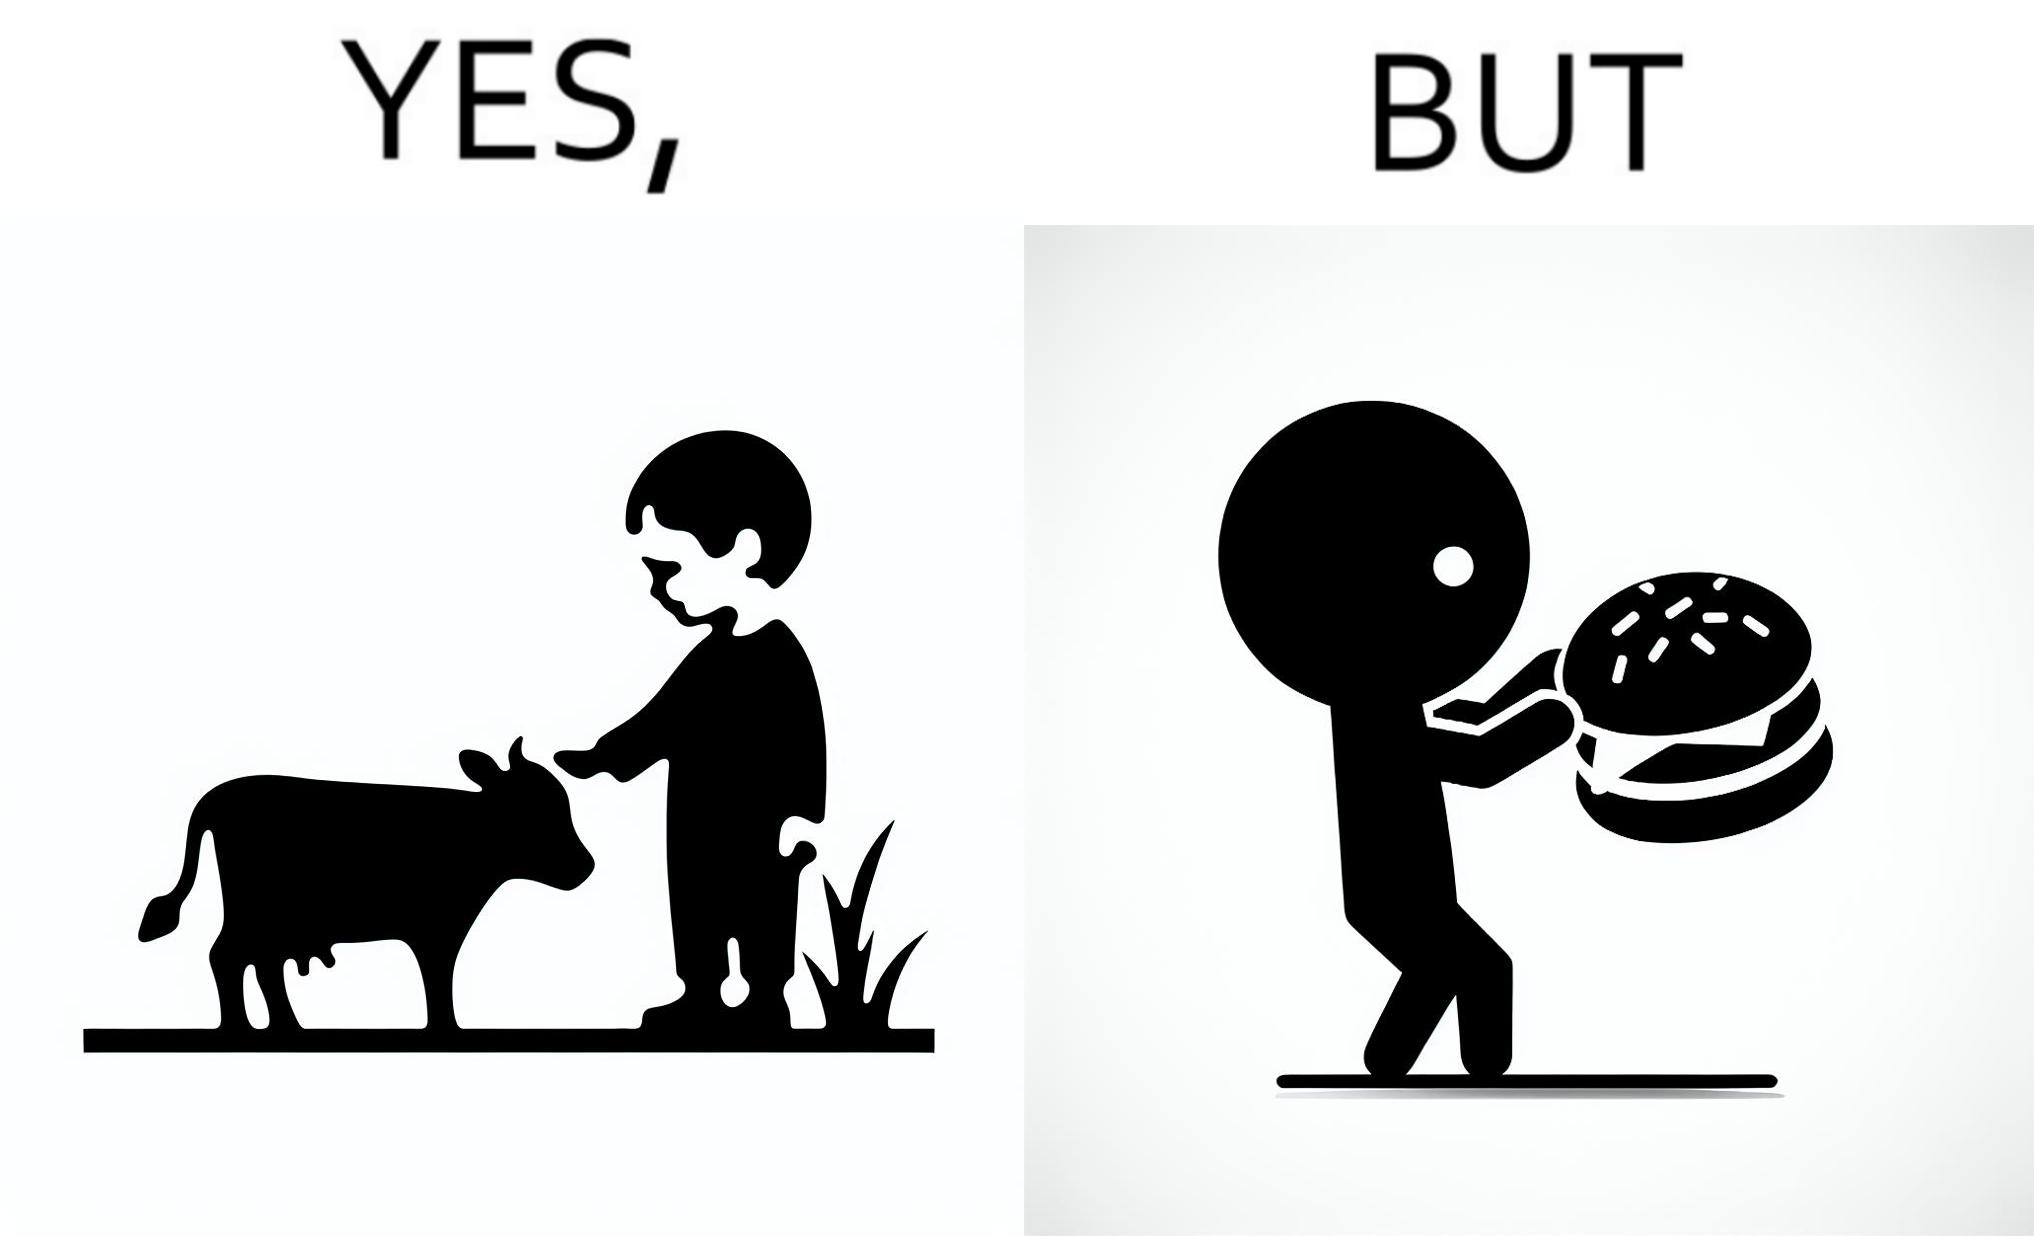What is shown in this image? The irony is that the boy is petting the cow to show that he cares about the animal, but then he also eats hamburgers made from the same cows 